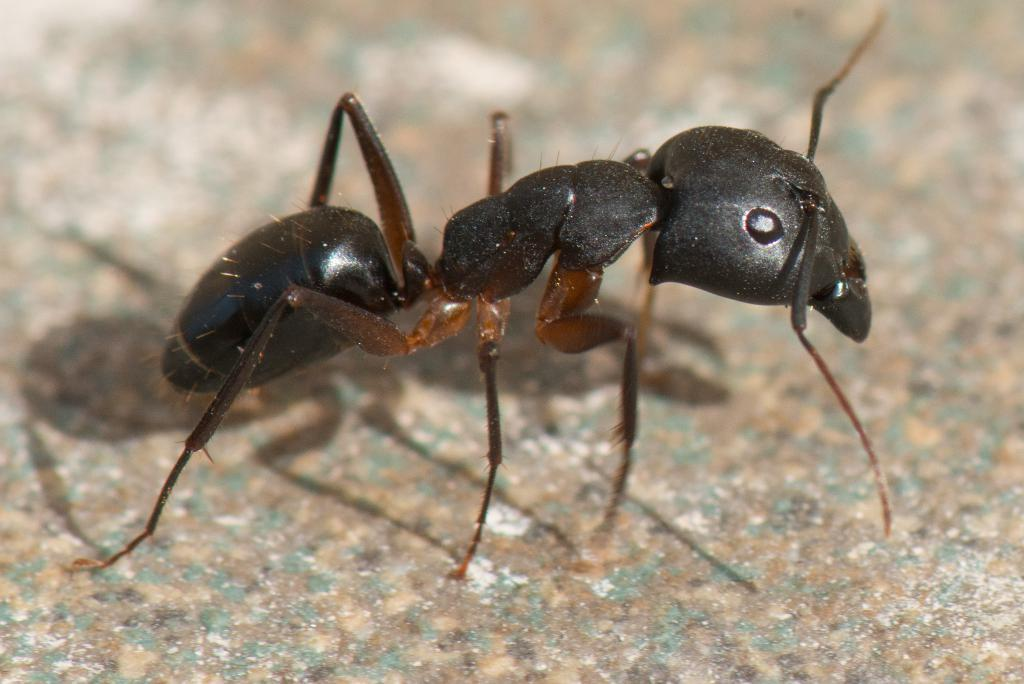What type of creature is in the image? There is an ant in the image. Where is the ant located? The ant is on the ground. What country is the ant from in the image? The image does not provide information about the ant's country of origin. How does the ant expand its territory in the image? The image does not show the ant expanding its territory; it only shows the ant on the ground. 